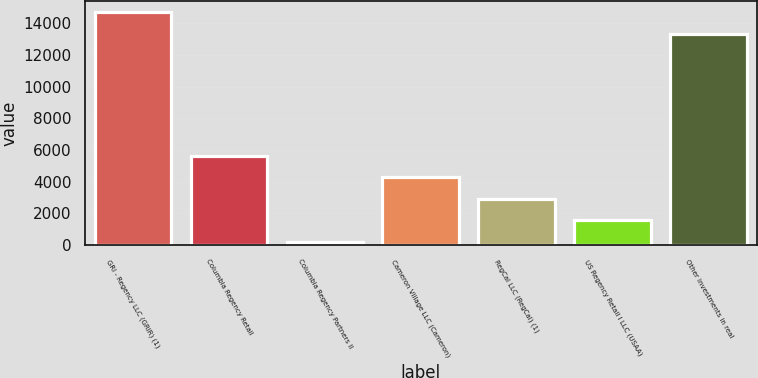<chart> <loc_0><loc_0><loc_500><loc_500><bar_chart><fcel>GRI - Regency LLC (GRIR) (1)<fcel>Columbia Regency Retail<fcel>Columbia Regency Partners II<fcel>Cameron Village LLC (Cameron)<fcel>RegCal LLC (RegCal) (1)<fcel>US Regency Retail I LLC (USAA)<fcel>Other investments in real<nl><fcel>14687.4<fcel>5630.6<fcel>233<fcel>4281.2<fcel>2931.8<fcel>1582.4<fcel>13338<nl></chart> 